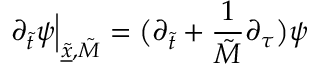<formula> <loc_0><loc_0><loc_500><loc_500>\partial _ { \tilde { t } } \psi \Big | _ { \underline { { \tilde { x } } } , \tilde { M } } = \Big ( \partial _ { \tilde { t } } + \frac { 1 } { \tilde { M } } \partial _ { \tau } \Big ) \psi</formula> 